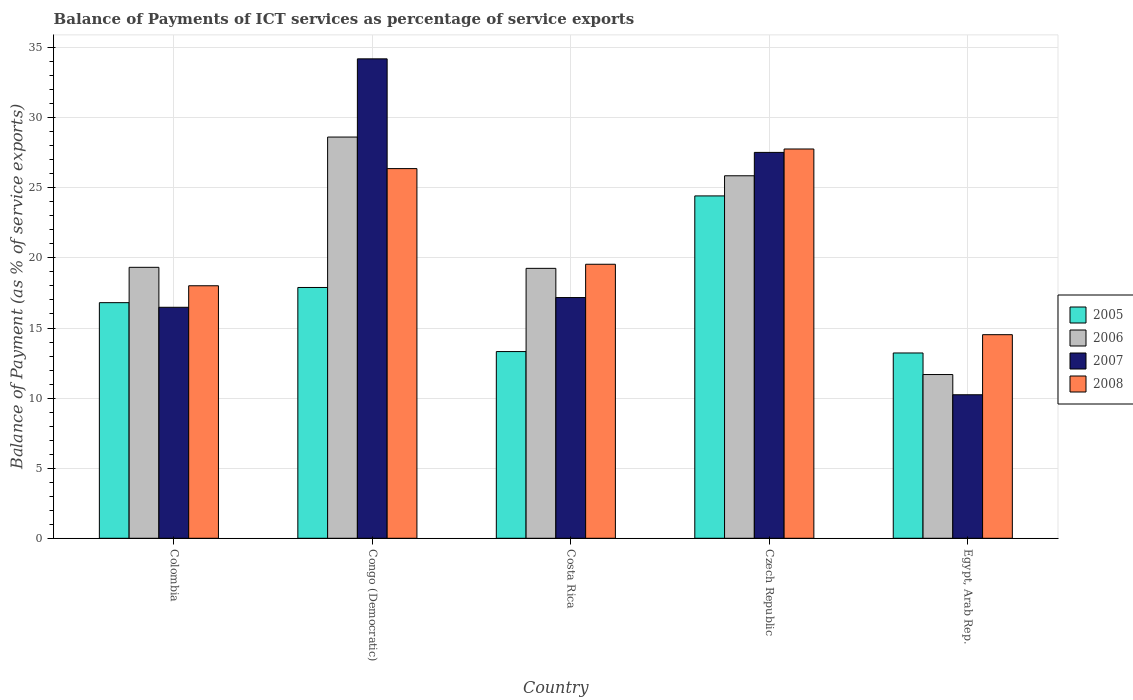How many groups of bars are there?
Make the answer very short. 5. Are the number of bars per tick equal to the number of legend labels?
Provide a short and direct response. Yes. How many bars are there on the 3rd tick from the right?
Provide a succinct answer. 4. What is the label of the 4th group of bars from the left?
Provide a succinct answer. Czech Republic. What is the balance of payments of ICT services in 2008 in Colombia?
Offer a very short reply. 18.01. Across all countries, what is the maximum balance of payments of ICT services in 2005?
Ensure brevity in your answer.  24.42. Across all countries, what is the minimum balance of payments of ICT services in 2005?
Keep it short and to the point. 13.22. In which country was the balance of payments of ICT services in 2007 maximum?
Your answer should be compact. Congo (Democratic). In which country was the balance of payments of ICT services in 2007 minimum?
Keep it short and to the point. Egypt, Arab Rep. What is the total balance of payments of ICT services in 2008 in the graph?
Offer a very short reply. 106.22. What is the difference between the balance of payments of ICT services in 2007 in Czech Republic and that in Egypt, Arab Rep.?
Ensure brevity in your answer.  17.29. What is the difference between the balance of payments of ICT services in 2006 in Egypt, Arab Rep. and the balance of payments of ICT services in 2005 in Czech Republic?
Your answer should be compact. -12.74. What is the average balance of payments of ICT services in 2007 per country?
Make the answer very short. 21.12. What is the difference between the balance of payments of ICT services of/in 2008 and balance of payments of ICT services of/in 2005 in Costa Rica?
Your response must be concise. 6.23. In how many countries, is the balance of payments of ICT services in 2008 greater than 23 %?
Provide a short and direct response. 2. What is the ratio of the balance of payments of ICT services in 2007 in Congo (Democratic) to that in Egypt, Arab Rep.?
Ensure brevity in your answer.  3.34. What is the difference between the highest and the second highest balance of payments of ICT services in 2005?
Your answer should be very brief. 6.53. What is the difference between the highest and the lowest balance of payments of ICT services in 2008?
Your response must be concise. 13.24. In how many countries, is the balance of payments of ICT services in 2007 greater than the average balance of payments of ICT services in 2007 taken over all countries?
Your answer should be very brief. 2. Is it the case that in every country, the sum of the balance of payments of ICT services in 2005 and balance of payments of ICT services in 2008 is greater than the sum of balance of payments of ICT services in 2006 and balance of payments of ICT services in 2007?
Offer a terse response. No. What does the 2nd bar from the right in Congo (Democratic) represents?
Offer a terse response. 2007. Is it the case that in every country, the sum of the balance of payments of ICT services in 2007 and balance of payments of ICT services in 2008 is greater than the balance of payments of ICT services in 2006?
Offer a very short reply. Yes. Are all the bars in the graph horizontal?
Ensure brevity in your answer.  No. How many countries are there in the graph?
Give a very brief answer. 5. What is the difference between two consecutive major ticks on the Y-axis?
Make the answer very short. 5. Are the values on the major ticks of Y-axis written in scientific E-notation?
Your answer should be compact. No. Does the graph contain grids?
Ensure brevity in your answer.  Yes. What is the title of the graph?
Your response must be concise. Balance of Payments of ICT services as percentage of service exports. Does "1994" appear as one of the legend labels in the graph?
Your response must be concise. No. What is the label or title of the Y-axis?
Ensure brevity in your answer.  Balance of Payment (as % of service exports). What is the Balance of Payment (as % of service exports) in 2005 in Colombia?
Your answer should be compact. 16.81. What is the Balance of Payment (as % of service exports) of 2006 in Colombia?
Keep it short and to the point. 19.33. What is the Balance of Payment (as % of service exports) of 2007 in Colombia?
Provide a short and direct response. 16.48. What is the Balance of Payment (as % of service exports) in 2008 in Colombia?
Provide a short and direct response. 18.01. What is the Balance of Payment (as % of service exports) of 2005 in Congo (Democratic)?
Make the answer very short. 17.89. What is the Balance of Payment (as % of service exports) of 2006 in Congo (Democratic)?
Your response must be concise. 28.62. What is the Balance of Payment (as % of service exports) of 2007 in Congo (Democratic)?
Offer a terse response. 34.2. What is the Balance of Payment (as % of service exports) of 2008 in Congo (Democratic)?
Offer a terse response. 26.37. What is the Balance of Payment (as % of service exports) in 2005 in Costa Rica?
Provide a succinct answer. 13.32. What is the Balance of Payment (as % of service exports) in 2006 in Costa Rica?
Offer a very short reply. 19.25. What is the Balance of Payment (as % of service exports) in 2007 in Costa Rica?
Give a very brief answer. 17.17. What is the Balance of Payment (as % of service exports) in 2008 in Costa Rica?
Offer a terse response. 19.55. What is the Balance of Payment (as % of service exports) in 2005 in Czech Republic?
Your answer should be compact. 24.42. What is the Balance of Payment (as % of service exports) of 2006 in Czech Republic?
Offer a terse response. 25.86. What is the Balance of Payment (as % of service exports) of 2007 in Czech Republic?
Your answer should be very brief. 27.53. What is the Balance of Payment (as % of service exports) of 2008 in Czech Republic?
Your response must be concise. 27.77. What is the Balance of Payment (as % of service exports) in 2005 in Egypt, Arab Rep.?
Provide a short and direct response. 13.22. What is the Balance of Payment (as % of service exports) of 2006 in Egypt, Arab Rep.?
Your answer should be compact. 11.68. What is the Balance of Payment (as % of service exports) of 2007 in Egypt, Arab Rep.?
Offer a very short reply. 10.24. What is the Balance of Payment (as % of service exports) of 2008 in Egypt, Arab Rep.?
Provide a succinct answer. 14.52. Across all countries, what is the maximum Balance of Payment (as % of service exports) in 2005?
Provide a succinct answer. 24.42. Across all countries, what is the maximum Balance of Payment (as % of service exports) of 2006?
Offer a very short reply. 28.62. Across all countries, what is the maximum Balance of Payment (as % of service exports) in 2007?
Provide a succinct answer. 34.2. Across all countries, what is the maximum Balance of Payment (as % of service exports) in 2008?
Ensure brevity in your answer.  27.77. Across all countries, what is the minimum Balance of Payment (as % of service exports) in 2005?
Keep it short and to the point. 13.22. Across all countries, what is the minimum Balance of Payment (as % of service exports) in 2006?
Offer a very short reply. 11.68. Across all countries, what is the minimum Balance of Payment (as % of service exports) in 2007?
Make the answer very short. 10.24. Across all countries, what is the minimum Balance of Payment (as % of service exports) of 2008?
Offer a terse response. 14.52. What is the total Balance of Payment (as % of service exports) in 2005 in the graph?
Make the answer very short. 85.66. What is the total Balance of Payment (as % of service exports) in 2006 in the graph?
Offer a terse response. 104.74. What is the total Balance of Payment (as % of service exports) in 2007 in the graph?
Give a very brief answer. 105.61. What is the total Balance of Payment (as % of service exports) in 2008 in the graph?
Keep it short and to the point. 106.22. What is the difference between the Balance of Payment (as % of service exports) in 2005 in Colombia and that in Congo (Democratic)?
Your response must be concise. -1.08. What is the difference between the Balance of Payment (as % of service exports) of 2006 in Colombia and that in Congo (Democratic)?
Your response must be concise. -9.29. What is the difference between the Balance of Payment (as % of service exports) in 2007 in Colombia and that in Congo (Democratic)?
Provide a succinct answer. -17.72. What is the difference between the Balance of Payment (as % of service exports) in 2008 in Colombia and that in Congo (Democratic)?
Ensure brevity in your answer.  -8.36. What is the difference between the Balance of Payment (as % of service exports) in 2005 in Colombia and that in Costa Rica?
Your answer should be very brief. 3.49. What is the difference between the Balance of Payment (as % of service exports) in 2006 in Colombia and that in Costa Rica?
Ensure brevity in your answer.  0.07. What is the difference between the Balance of Payment (as % of service exports) in 2007 in Colombia and that in Costa Rica?
Your answer should be compact. -0.69. What is the difference between the Balance of Payment (as % of service exports) of 2008 in Colombia and that in Costa Rica?
Give a very brief answer. -1.53. What is the difference between the Balance of Payment (as % of service exports) of 2005 in Colombia and that in Czech Republic?
Your response must be concise. -7.61. What is the difference between the Balance of Payment (as % of service exports) in 2006 in Colombia and that in Czech Republic?
Your response must be concise. -6.53. What is the difference between the Balance of Payment (as % of service exports) in 2007 in Colombia and that in Czech Republic?
Keep it short and to the point. -11.05. What is the difference between the Balance of Payment (as % of service exports) in 2008 in Colombia and that in Czech Republic?
Offer a terse response. -9.76. What is the difference between the Balance of Payment (as % of service exports) of 2005 in Colombia and that in Egypt, Arab Rep.?
Offer a terse response. 3.59. What is the difference between the Balance of Payment (as % of service exports) in 2006 in Colombia and that in Egypt, Arab Rep.?
Give a very brief answer. 7.65. What is the difference between the Balance of Payment (as % of service exports) in 2007 in Colombia and that in Egypt, Arab Rep.?
Provide a short and direct response. 6.24. What is the difference between the Balance of Payment (as % of service exports) of 2008 in Colombia and that in Egypt, Arab Rep.?
Offer a terse response. 3.49. What is the difference between the Balance of Payment (as % of service exports) of 2005 in Congo (Democratic) and that in Costa Rica?
Keep it short and to the point. 4.57. What is the difference between the Balance of Payment (as % of service exports) in 2006 in Congo (Democratic) and that in Costa Rica?
Give a very brief answer. 9.37. What is the difference between the Balance of Payment (as % of service exports) in 2007 in Congo (Democratic) and that in Costa Rica?
Offer a terse response. 17.03. What is the difference between the Balance of Payment (as % of service exports) in 2008 in Congo (Democratic) and that in Costa Rica?
Your answer should be compact. 6.82. What is the difference between the Balance of Payment (as % of service exports) in 2005 in Congo (Democratic) and that in Czech Republic?
Offer a terse response. -6.53. What is the difference between the Balance of Payment (as % of service exports) of 2006 in Congo (Democratic) and that in Czech Republic?
Give a very brief answer. 2.76. What is the difference between the Balance of Payment (as % of service exports) in 2007 in Congo (Democratic) and that in Czech Republic?
Offer a terse response. 6.67. What is the difference between the Balance of Payment (as % of service exports) of 2008 in Congo (Democratic) and that in Czech Republic?
Offer a terse response. -1.4. What is the difference between the Balance of Payment (as % of service exports) in 2005 in Congo (Democratic) and that in Egypt, Arab Rep.?
Your answer should be compact. 4.67. What is the difference between the Balance of Payment (as % of service exports) of 2006 in Congo (Democratic) and that in Egypt, Arab Rep.?
Your response must be concise. 16.94. What is the difference between the Balance of Payment (as % of service exports) in 2007 in Congo (Democratic) and that in Egypt, Arab Rep.?
Your answer should be very brief. 23.96. What is the difference between the Balance of Payment (as % of service exports) in 2008 in Congo (Democratic) and that in Egypt, Arab Rep.?
Offer a terse response. 11.85. What is the difference between the Balance of Payment (as % of service exports) in 2005 in Costa Rica and that in Czech Republic?
Provide a short and direct response. -11.1. What is the difference between the Balance of Payment (as % of service exports) in 2006 in Costa Rica and that in Czech Republic?
Your answer should be compact. -6.6. What is the difference between the Balance of Payment (as % of service exports) in 2007 in Costa Rica and that in Czech Republic?
Provide a short and direct response. -10.36. What is the difference between the Balance of Payment (as % of service exports) in 2008 in Costa Rica and that in Czech Republic?
Your response must be concise. -8.22. What is the difference between the Balance of Payment (as % of service exports) in 2005 in Costa Rica and that in Egypt, Arab Rep.?
Offer a very short reply. 0.1. What is the difference between the Balance of Payment (as % of service exports) in 2006 in Costa Rica and that in Egypt, Arab Rep.?
Ensure brevity in your answer.  7.57. What is the difference between the Balance of Payment (as % of service exports) of 2007 in Costa Rica and that in Egypt, Arab Rep.?
Offer a terse response. 6.93. What is the difference between the Balance of Payment (as % of service exports) of 2008 in Costa Rica and that in Egypt, Arab Rep.?
Provide a short and direct response. 5.02. What is the difference between the Balance of Payment (as % of service exports) of 2005 in Czech Republic and that in Egypt, Arab Rep.?
Offer a very short reply. 11.2. What is the difference between the Balance of Payment (as % of service exports) of 2006 in Czech Republic and that in Egypt, Arab Rep.?
Offer a terse response. 14.18. What is the difference between the Balance of Payment (as % of service exports) in 2007 in Czech Republic and that in Egypt, Arab Rep.?
Keep it short and to the point. 17.29. What is the difference between the Balance of Payment (as % of service exports) of 2008 in Czech Republic and that in Egypt, Arab Rep.?
Provide a short and direct response. 13.24. What is the difference between the Balance of Payment (as % of service exports) in 2005 in Colombia and the Balance of Payment (as % of service exports) in 2006 in Congo (Democratic)?
Your response must be concise. -11.81. What is the difference between the Balance of Payment (as % of service exports) of 2005 in Colombia and the Balance of Payment (as % of service exports) of 2007 in Congo (Democratic)?
Your answer should be compact. -17.39. What is the difference between the Balance of Payment (as % of service exports) of 2005 in Colombia and the Balance of Payment (as % of service exports) of 2008 in Congo (Democratic)?
Your answer should be compact. -9.56. What is the difference between the Balance of Payment (as % of service exports) of 2006 in Colombia and the Balance of Payment (as % of service exports) of 2007 in Congo (Democratic)?
Offer a very short reply. -14.87. What is the difference between the Balance of Payment (as % of service exports) in 2006 in Colombia and the Balance of Payment (as % of service exports) in 2008 in Congo (Democratic)?
Make the answer very short. -7.04. What is the difference between the Balance of Payment (as % of service exports) in 2007 in Colombia and the Balance of Payment (as % of service exports) in 2008 in Congo (Democratic)?
Keep it short and to the point. -9.89. What is the difference between the Balance of Payment (as % of service exports) in 2005 in Colombia and the Balance of Payment (as % of service exports) in 2006 in Costa Rica?
Give a very brief answer. -2.45. What is the difference between the Balance of Payment (as % of service exports) of 2005 in Colombia and the Balance of Payment (as % of service exports) of 2007 in Costa Rica?
Keep it short and to the point. -0.36. What is the difference between the Balance of Payment (as % of service exports) of 2005 in Colombia and the Balance of Payment (as % of service exports) of 2008 in Costa Rica?
Offer a very short reply. -2.74. What is the difference between the Balance of Payment (as % of service exports) in 2006 in Colombia and the Balance of Payment (as % of service exports) in 2007 in Costa Rica?
Offer a very short reply. 2.16. What is the difference between the Balance of Payment (as % of service exports) in 2006 in Colombia and the Balance of Payment (as % of service exports) in 2008 in Costa Rica?
Your answer should be compact. -0.22. What is the difference between the Balance of Payment (as % of service exports) in 2007 in Colombia and the Balance of Payment (as % of service exports) in 2008 in Costa Rica?
Your answer should be compact. -3.07. What is the difference between the Balance of Payment (as % of service exports) of 2005 in Colombia and the Balance of Payment (as % of service exports) of 2006 in Czech Republic?
Offer a very short reply. -9.05. What is the difference between the Balance of Payment (as % of service exports) in 2005 in Colombia and the Balance of Payment (as % of service exports) in 2007 in Czech Republic?
Keep it short and to the point. -10.72. What is the difference between the Balance of Payment (as % of service exports) of 2005 in Colombia and the Balance of Payment (as % of service exports) of 2008 in Czech Republic?
Provide a succinct answer. -10.96. What is the difference between the Balance of Payment (as % of service exports) in 2006 in Colombia and the Balance of Payment (as % of service exports) in 2007 in Czech Republic?
Make the answer very short. -8.2. What is the difference between the Balance of Payment (as % of service exports) in 2006 in Colombia and the Balance of Payment (as % of service exports) in 2008 in Czech Republic?
Provide a short and direct response. -8.44. What is the difference between the Balance of Payment (as % of service exports) in 2007 in Colombia and the Balance of Payment (as % of service exports) in 2008 in Czech Republic?
Provide a succinct answer. -11.29. What is the difference between the Balance of Payment (as % of service exports) of 2005 in Colombia and the Balance of Payment (as % of service exports) of 2006 in Egypt, Arab Rep.?
Offer a terse response. 5.13. What is the difference between the Balance of Payment (as % of service exports) of 2005 in Colombia and the Balance of Payment (as % of service exports) of 2007 in Egypt, Arab Rep.?
Provide a succinct answer. 6.57. What is the difference between the Balance of Payment (as % of service exports) of 2005 in Colombia and the Balance of Payment (as % of service exports) of 2008 in Egypt, Arab Rep.?
Provide a short and direct response. 2.28. What is the difference between the Balance of Payment (as % of service exports) of 2006 in Colombia and the Balance of Payment (as % of service exports) of 2007 in Egypt, Arab Rep.?
Offer a very short reply. 9.09. What is the difference between the Balance of Payment (as % of service exports) of 2006 in Colombia and the Balance of Payment (as % of service exports) of 2008 in Egypt, Arab Rep.?
Your answer should be very brief. 4.8. What is the difference between the Balance of Payment (as % of service exports) of 2007 in Colombia and the Balance of Payment (as % of service exports) of 2008 in Egypt, Arab Rep.?
Keep it short and to the point. 1.95. What is the difference between the Balance of Payment (as % of service exports) of 2005 in Congo (Democratic) and the Balance of Payment (as % of service exports) of 2006 in Costa Rica?
Your answer should be very brief. -1.36. What is the difference between the Balance of Payment (as % of service exports) of 2005 in Congo (Democratic) and the Balance of Payment (as % of service exports) of 2007 in Costa Rica?
Ensure brevity in your answer.  0.72. What is the difference between the Balance of Payment (as % of service exports) in 2005 in Congo (Democratic) and the Balance of Payment (as % of service exports) in 2008 in Costa Rica?
Your answer should be compact. -1.66. What is the difference between the Balance of Payment (as % of service exports) in 2006 in Congo (Democratic) and the Balance of Payment (as % of service exports) in 2007 in Costa Rica?
Your response must be concise. 11.45. What is the difference between the Balance of Payment (as % of service exports) of 2006 in Congo (Democratic) and the Balance of Payment (as % of service exports) of 2008 in Costa Rica?
Offer a very short reply. 9.07. What is the difference between the Balance of Payment (as % of service exports) of 2007 in Congo (Democratic) and the Balance of Payment (as % of service exports) of 2008 in Costa Rica?
Your answer should be compact. 14.65. What is the difference between the Balance of Payment (as % of service exports) in 2005 in Congo (Democratic) and the Balance of Payment (as % of service exports) in 2006 in Czech Republic?
Ensure brevity in your answer.  -7.97. What is the difference between the Balance of Payment (as % of service exports) in 2005 in Congo (Democratic) and the Balance of Payment (as % of service exports) in 2007 in Czech Republic?
Make the answer very short. -9.64. What is the difference between the Balance of Payment (as % of service exports) of 2005 in Congo (Democratic) and the Balance of Payment (as % of service exports) of 2008 in Czech Republic?
Provide a short and direct response. -9.88. What is the difference between the Balance of Payment (as % of service exports) in 2006 in Congo (Democratic) and the Balance of Payment (as % of service exports) in 2007 in Czech Republic?
Ensure brevity in your answer.  1.09. What is the difference between the Balance of Payment (as % of service exports) in 2006 in Congo (Democratic) and the Balance of Payment (as % of service exports) in 2008 in Czech Republic?
Offer a terse response. 0.85. What is the difference between the Balance of Payment (as % of service exports) of 2007 in Congo (Democratic) and the Balance of Payment (as % of service exports) of 2008 in Czech Republic?
Give a very brief answer. 6.43. What is the difference between the Balance of Payment (as % of service exports) in 2005 in Congo (Democratic) and the Balance of Payment (as % of service exports) in 2006 in Egypt, Arab Rep.?
Make the answer very short. 6.21. What is the difference between the Balance of Payment (as % of service exports) in 2005 in Congo (Democratic) and the Balance of Payment (as % of service exports) in 2007 in Egypt, Arab Rep.?
Your answer should be very brief. 7.65. What is the difference between the Balance of Payment (as % of service exports) of 2005 in Congo (Democratic) and the Balance of Payment (as % of service exports) of 2008 in Egypt, Arab Rep.?
Offer a very short reply. 3.37. What is the difference between the Balance of Payment (as % of service exports) of 2006 in Congo (Democratic) and the Balance of Payment (as % of service exports) of 2007 in Egypt, Arab Rep.?
Provide a succinct answer. 18.38. What is the difference between the Balance of Payment (as % of service exports) in 2006 in Congo (Democratic) and the Balance of Payment (as % of service exports) in 2008 in Egypt, Arab Rep.?
Offer a very short reply. 14.1. What is the difference between the Balance of Payment (as % of service exports) of 2007 in Congo (Democratic) and the Balance of Payment (as % of service exports) of 2008 in Egypt, Arab Rep.?
Give a very brief answer. 19.68. What is the difference between the Balance of Payment (as % of service exports) in 2005 in Costa Rica and the Balance of Payment (as % of service exports) in 2006 in Czech Republic?
Your response must be concise. -12.54. What is the difference between the Balance of Payment (as % of service exports) of 2005 in Costa Rica and the Balance of Payment (as % of service exports) of 2007 in Czech Republic?
Your response must be concise. -14.21. What is the difference between the Balance of Payment (as % of service exports) in 2005 in Costa Rica and the Balance of Payment (as % of service exports) in 2008 in Czech Republic?
Your response must be concise. -14.45. What is the difference between the Balance of Payment (as % of service exports) of 2006 in Costa Rica and the Balance of Payment (as % of service exports) of 2007 in Czech Republic?
Your answer should be compact. -8.27. What is the difference between the Balance of Payment (as % of service exports) of 2006 in Costa Rica and the Balance of Payment (as % of service exports) of 2008 in Czech Republic?
Your response must be concise. -8.51. What is the difference between the Balance of Payment (as % of service exports) of 2007 in Costa Rica and the Balance of Payment (as % of service exports) of 2008 in Czech Republic?
Provide a short and direct response. -10.6. What is the difference between the Balance of Payment (as % of service exports) of 2005 in Costa Rica and the Balance of Payment (as % of service exports) of 2006 in Egypt, Arab Rep.?
Your answer should be compact. 1.64. What is the difference between the Balance of Payment (as % of service exports) in 2005 in Costa Rica and the Balance of Payment (as % of service exports) in 2007 in Egypt, Arab Rep.?
Your response must be concise. 3.08. What is the difference between the Balance of Payment (as % of service exports) of 2005 in Costa Rica and the Balance of Payment (as % of service exports) of 2008 in Egypt, Arab Rep.?
Your response must be concise. -1.21. What is the difference between the Balance of Payment (as % of service exports) of 2006 in Costa Rica and the Balance of Payment (as % of service exports) of 2007 in Egypt, Arab Rep.?
Give a very brief answer. 9.02. What is the difference between the Balance of Payment (as % of service exports) of 2006 in Costa Rica and the Balance of Payment (as % of service exports) of 2008 in Egypt, Arab Rep.?
Your response must be concise. 4.73. What is the difference between the Balance of Payment (as % of service exports) in 2007 in Costa Rica and the Balance of Payment (as % of service exports) in 2008 in Egypt, Arab Rep.?
Keep it short and to the point. 2.65. What is the difference between the Balance of Payment (as % of service exports) in 2005 in Czech Republic and the Balance of Payment (as % of service exports) in 2006 in Egypt, Arab Rep.?
Ensure brevity in your answer.  12.74. What is the difference between the Balance of Payment (as % of service exports) in 2005 in Czech Republic and the Balance of Payment (as % of service exports) in 2007 in Egypt, Arab Rep.?
Offer a very short reply. 14.18. What is the difference between the Balance of Payment (as % of service exports) of 2005 in Czech Republic and the Balance of Payment (as % of service exports) of 2008 in Egypt, Arab Rep.?
Provide a succinct answer. 9.9. What is the difference between the Balance of Payment (as % of service exports) of 2006 in Czech Republic and the Balance of Payment (as % of service exports) of 2007 in Egypt, Arab Rep.?
Your answer should be very brief. 15.62. What is the difference between the Balance of Payment (as % of service exports) of 2006 in Czech Republic and the Balance of Payment (as % of service exports) of 2008 in Egypt, Arab Rep.?
Your response must be concise. 11.34. What is the difference between the Balance of Payment (as % of service exports) in 2007 in Czech Republic and the Balance of Payment (as % of service exports) in 2008 in Egypt, Arab Rep.?
Provide a short and direct response. 13. What is the average Balance of Payment (as % of service exports) in 2005 per country?
Offer a very short reply. 17.13. What is the average Balance of Payment (as % of service exports) in 2006 per country?
Your response must be concise. 20.95. What is the average Balance of Payment (as % of service exports) in 2007 per country?
Your answer should be compact. 21.12. What is the average Balance of Payment (as % of service exports) in 2008 per country?
Make the answer very short. 21.24. What is the difference between the Balance of Payment (as % of service exports) of 2005 and Balance of Payment (as % of service exports) of 2006 in Colombia?
Ensure brevity in your answer.  -2.52. What is the difference between the Balance of Payment (as % of service exports) of 2005 and Balance of Payment (as % of service exports) of 2007 in Colombia?
Give a very brief answer. 0.33. What is the difference between the Balance of Payment (as % of service exports) in 2005 and Balance of Payment (as % of service exports) in 2008 in Colombia?
Give a very brief answer. -1.21. What is the difference between the Balance of Payment (as % of service exports) in 2006 and Balance of Payment (as % of service exports) in 2007 in Colombia?
Give a very brief answer. 2.85. What is the difference between the Balance of Payment (as % of service exports) of 2006 and Balance of Payment (as % of service exports) of 2008 in Colombia?
Give a very brief answer. 1.32. What is the difference between the Balance of Payment (as % of service exports) of 2007 and Balance of Payment (as % of service exports) of 2008 in Colombia?
Your answer should be compact. -1.54. What is the difference between the Balance of Payment (as % of service exports) in 2005 and Balance of Payment (as % of service exports) in 2006 in Congo (Democratic)?
Provide a short and direct response. -10.73. What is the difference between the Balance of Payment (as % of service exports) of 2005 and Balance of Payment (as % of service exports) of 2007 in Congo (Democratic)?
Keep it short and to the point. -16.31. What is the difference between the Balance of Payment (as % of service exports) of 2005 and Balance of Payment (as % of service exports) of 2008 in Congo (Democratic)?
Give a very brief answer. -8.48. What is the difference between the Balance of Payment (as % of service exports) in 2006 and Balance of Payment (as % of service exports) in 2007 in Congo (Democratic)?
Give a very brief answer. -5.58. What is the difference between the Balance of Payment (as % of service exports) of 2006 and Balance of Payment (as % of service exports) of 2008 in Congo (Democratic)?
Keep it short and to the point. 2.25. What is the difference between the Balance of Payment (as % of service exports) of 2007 and Balance of Payment (as % of service exports) of 2008 in Congo (Democratic)?
Give a very brief answer. 7.83. What is the difference between the Balance of Payment (as % of service exports) in 2005 and Balance of Payment (as % of service exports) in 2006 in Costa Rica?
Provide a succinct answer. -5.94. What is the difference between the Balance of Payment (as % of service exports) in 2005 and Balance of Payment (as % of service exports) in 2007 in Costa Rica?
Keep it short and to the point. -3.85. What is the difference between the Balance of Payment (as % of service exports) in 2005 and Balance of Payment (as % of service exports) in 2008 in Costa Rica?
Offer a very short reply. -6.23. What is the difference between the Balance of Payment (as % of service exports) in 2006 and Balance of Payment (as % of service exports) in 2007 in Costa Rica?
Ensure brevity in your answer.  2.08. What is the difference between the Balance of Payment (as % of service exports) in 2006 and Balance of Payment (as % of service exports) in 2008 in Costa Rica?
Offer a very short reply. -0.29. What is the difference between the Balance of Payment (as % of service exports) in 2007 and Balance of Payment (as % of service exports) in 2008 in Costa Rica?
Give a very brief answer. -2.38. What is the difference between the Balance of Payment (as % of service exports) of 2005 and Balance of Payment (as % of service exports) of 2006 in Czech Republic?
Give a very brief answer. -1.44. What is the difference between the Balance of Payment (as % of service exports) of 2005 and Balance of Payment (as % of service exports) of 2007 in Czech Republic?
Your answer should be compact. -3.1. What is the difference between the Balance of Payment (as % of service exports) of 2005 and Balance of Payment (as % of service exports) of 2008 in Czech Republic?
Offer a terse response. -3.35. What is the difference between the Balance of Payment (as % of service exports) of 2006 and Balance of Payment (as % of service exports) of 2007 in Czech Republic?
Make the answer very short. -1.67. What is the difference between the Balance of Payment (as % of service exports) of 2006 and Balance of Payment (as % of service exports) of 2008 in Czech Republic?
Your response must be concise. -1.91. What is the difference between the Balance of Payment (as % of service exports) in 2007 and Balance of Payment (as % of service exports) in 2008 in Czech Republic?
Make the answer very short. -0.24. What is the difference between the Balance of Payment (as % of service exports) in 2005 and Balance of Payment (as % of service exports) in 2006 in Egypt, Arab Rep.?
Your answer should be very brief. 1.54. What is the difference between the Balance of Payment (as % of service exports) in 2005 and Balance of Payment (as % of service exports) in 2007 in Egypt, Arab Rep.?
Provide a succinct answer. 2.98. What is the difference between the Balance of Payment (as % of service exports) in 2005 and Balance of Payment (as % of service exports) in 2008 in Egypt, Arab Rep.?
Provide a succinct answer. -1.3. What is the difference between the Balance of Payment (as % of service exports) of 2006 and Balance of Payment (as % of service exports) of 2007 in Egypt, Arab Rep.?
Your answer should be compact. 1.44. What is the difference between the Balance of Payment (as % of service exports) in 2006 and Balance of Payment (as % of service exports) in 2008 in Egypt, Arab Rep.?
Your response must be concise. -2.84. What is the difference between the Balance of Payment (as % of service exports) of 2007 and Balance of Payment (as % of service exports) of 2008 in Egypt, Arab Rep.?
Keep it short and to the point. -4.29. What is the ratio of the Balance of Payment (as % of service exports) in 2005 in Colombia to that in Congo (Democratic)?
Give a very brief answer. 0.94. What is the ratio of the Balance of Payment (as % of service exports) of 2006 in Colombia to that in Congo (Democratic)?
Make the answer very short. 0.68. What is the ratio of the Balance of Payment (as % of service exports) in 2007 in Colombia to that in Congo (Democratic)?
Provide a short and direct response. 0.48. What is the ratio of the Balance of Payment (as % of service exports) of 2008 in Colombia to that in Congo (Democratic)?
Offer a terse response. 0.68. What is the ratio of the Balance of Payment (as % of service exports) in 2005 in Colombia to that in Costa Rica?
Provide a succinct answer. 1.26. What is the ratio of the Balance of Payment (as % of service exports) of 2007 in Colombia to that in Costa Rica?
Offer a very short reply. 0.96. What is the ratio of the Balance of Payment (as % of service exports) of 2008 in Colombia to that in Costa Rica?
Keep it short and to the point. 0.92. What is the ratio of the Balance of Payment (as % of service exports) of 2005 in Colombia to that in Czech Republic?
Your answer should be compact. 0.69. What is the ratio of the Balance of Payment (as % of service exports) in 2006 in Colombia to that in Czech Republic?
Your response must be concise. 0.75. What is the ratio of the Balance of Payment (as % of service exports) in 2007 in Colombia to that in Czech Republic?
Offer a terse response. 0.6. What is the ratio of the Balance of Payment (as % of service exports) in 2008 in Colombia to that in Czech Republic?
Offer a very short reply. 0.65. What is the ratio of the Balance of Payment (as % of service exports) in 2005 in Colombia to that in Egypt, Arab Rep.?
Ensure brevity in your answer.  1.27. What is the ratio of the Balance of Payment (as % of service exports) of 2006 in Colombia to that in Egypt, Arab Rep.?
Offer a very short reply. 1.65. What is the ratio of the Balance of Payment (as % of service exports) in 2007 in Colombia to that in Egypt, Arab Rep.?
Provide a short and direct response. 1.61. What is the ratio of the Balance of Payment (as % of service exports) of 2008 in Colombia to that in Egypt, Arab Rep.?
Your response must be concise. 1.24. What is the ratio of the Balance of Payment (as % of service exports) of 2005 in Congo (Democratic) to that in Costa Rica?
Give a very brief answer. 1.34. What is the ratio of the Balance of Payment (as % of service exports) of 2006 in Congo (Democratic) to that in Costa Rica?
Your answer should be very brief. 1.49. What is the ratio of the Balance of Payment (as % of service exports) in 2007 in Congo (Democratic) to that in Costa Rica?
Your answer should be compact. 1.99. What is the ratio of the Balance of Payment (as % of service exports) of 2008 in Congo (Democratic) to that in Costa Rica?
Your answer should be very brief. 1.35. What is the ratio of the Balance of Payment (as % of service exports) of 2005 in Congo (Democratic) to that in Czech Republic?
Keep it short and to the point. 0.73. What is the ratio of the Balance of Payment (as % of service exports) of 2006 in Congo (Democratic) to that in Czech Republic?
Provide a succinct answer. 1.11. What is the ratio of the Balance of Payment (as % of service exports) in 2007 in Congo (Democratic) to that in Czech Republic?
Ensure brevity in your answer.  1.24. What is the ratio of the Balance of Payment (as % of service exports) of 2008 in Congo (Democratic) to that in Czech Republic?
Your response must be concise. 0.95. What is the ratio of the Balance of Payment (as % of service exports) of 2005 in Congo (Democratic) to that in Egypt, Arab Rep.?
Offer a very short reply. 1.35. What is the ratio of the Balance of Payment (as % of service exports) in 2006 in Congo (Democratic) to that in Egypt, Arab Rep.?
Offer a terse response. 2.45. What is the ratio of the Balance of Payment (as % of service exports) in 2007 in Congo (Democratic) to that in Egypt, Arab Rep.?
Your response must be concise. 3.34. What is the ratio of the Balance of Payment (as % of service exports) of 2008 in Congo (Democratic) to that in Egypt, Arab Rep.?
Give a very brief answer. 1.82. What is the ratio of the Balance of Payment (as % of service exports) in 2005 in Costa Rica to that in Czech Republic?
Your answer should be very brief. 0.55. What is the ratio of the Balance of Payment (as % of service exports) of 2006 in Costa Rica to that in Czech Republic?
Your answer should be very brief. 0.74. What is the ratio of the Balance of Payment (as % of service exports) in 2007 in Costa Rica to that in Czech Republic?
Make the answer very short. 0.62. What is the ratio of the Balance of Payment (as % of service exports) of 2008 in Costa Rica to that in Czech Republic?
Your answer should be very brief. 0.7. What is the ratio of the Balance of Payment (as % of service exports) in 2005 in Costa Rica to that in Egypt, Arab Rep.?
Offer a terse response. 1.01. What is the ratio of the Balance of Payment (as % of service exports) in 2006 in Costa Rica to that in Egypt, Arab Rep.?
Offer a very short reply. 1.65. What is the ratio of the Balance of Payment (as % of service exports) in 2007 in Costa Rica to that in Egypt, Arab Rep.?
Offer a very short reply. 1.68. What is the ratio of the Balance of Payment (as % of service exports) of 2008 in Costa Rica to that in Egypt, Arab Rep.?
Offer a terse response. 1.35. What is the ratio of the Balance of Payment (as % of service exports) in 2005 in Czech Republic to that in Egypt, Arab Rep.?
Provide a short and direct response. 1.85. What is the ratio of the Balance of Payment (as % of service exports) of 2006 in Czech Republic to that in Egypt, Arab Rep.?
Ensure brevity in your answer.  2.21. What is the ratio of the Balance of Payment (as % of service exports) of 2007 in Czech Republic to that in Egypt, Arab Rep.?
Offer a very short reply. 2.69. What is the ratio of the Balance of Payment (as % of service exports) in 2008 in Czech Republic to that in Egypt, Arab Rep.?
Your answer should be compact. 1.91. What is the difference between the highest and the second highest Balance of Payment (as % of service exports) of 2005?
Make the answer very short. 6.53. What is the difference between the highest and the second highest Balance of Payment (as % of service exports) in 2006?
Your response must be concise. 2.76. What is the difference between the highest and the second highest Balance of Payment (as % of service exports) in 2007?
Your response must be concise. 6.67. What is the difference between the highest and the second highest Balance of Payment (as % of service exports) of 2008?
Your answer should be very brief. 1.4. What is the difference between the highest and the lowest Balance of Payment (as % of service exports) in 2005?
Give a very brief answer. 11.2. What is the difference between the highest and the lowest Balance of Payment (as % of service exports) of 2006?
Your answer should be very brief. 16.94. What is the difference between the highest and the lowest Balance of Payment (as % of service exports) of 2007?
Make the answer very short. 23.96. What is the difference between the highest and the lowest Balance of Payment (as % of service exports) of 2008?
Your answer should be compact. 13.24. 